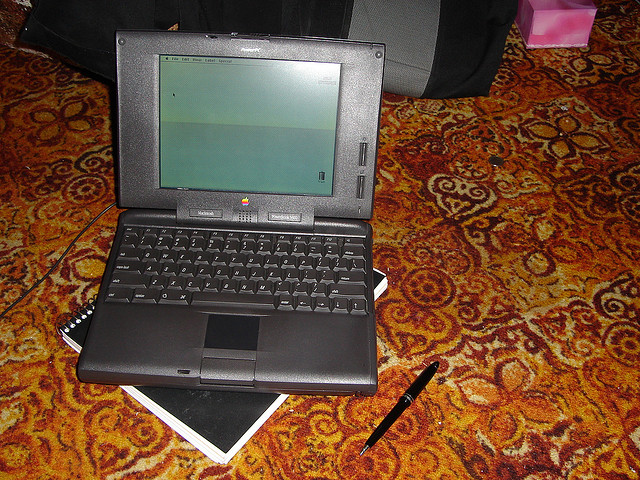Please transcribe the text information in this image. X Q W X C V B N M J H G F D S A 